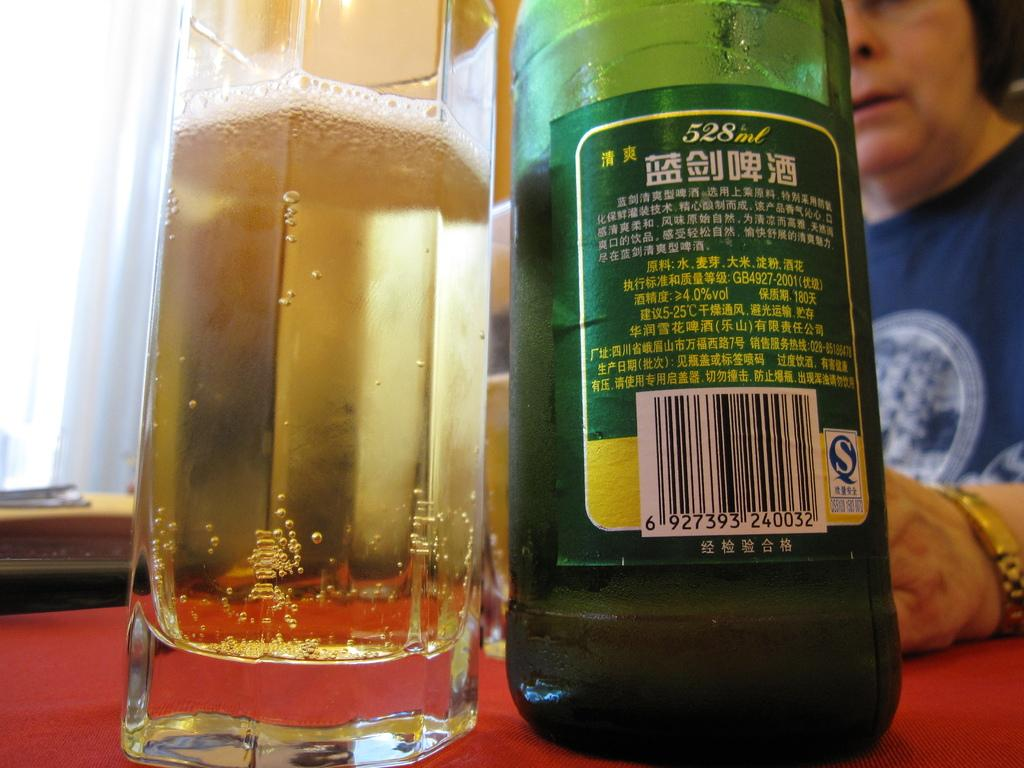Provide a one-sentence caption for the provided image. a 528ml bottle is sitting on a table with a red table cloth. 